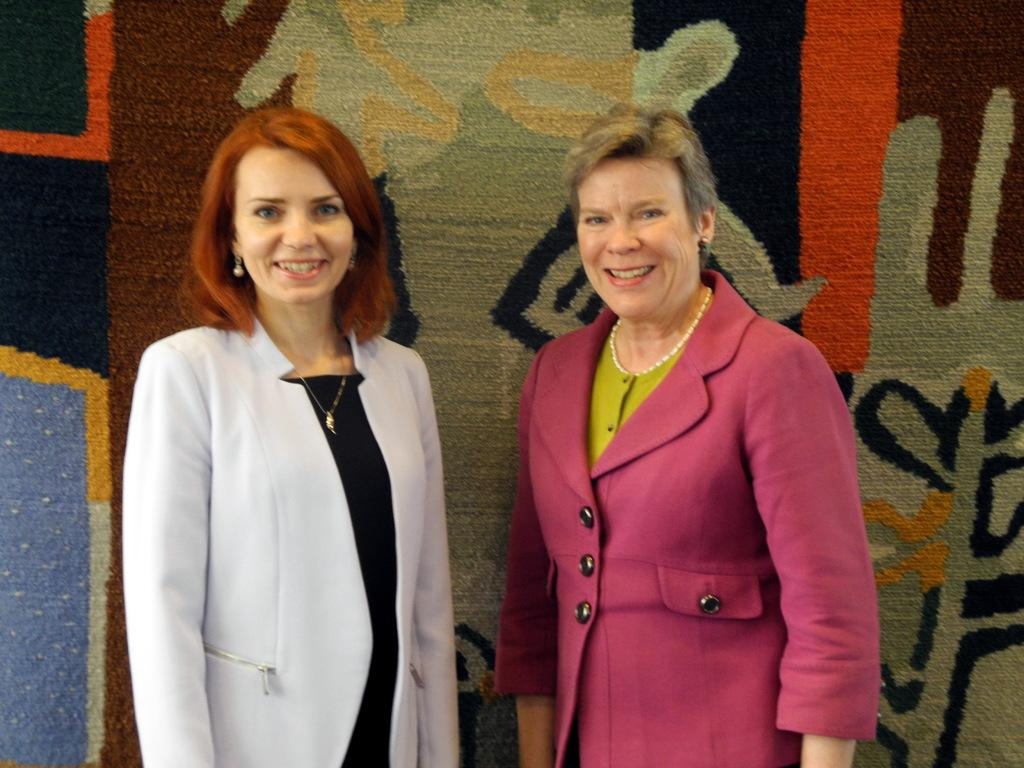How many people are in the image? There are two women in the picture. What are the women doing in the image? The women are standing and smiling. Can you describe the background of the image? There appears to be a cloth in the background of the image. What type of care can be seen being provided to the park in the image? There is no park or care being provided in the image; it features two women standing and smiling. 